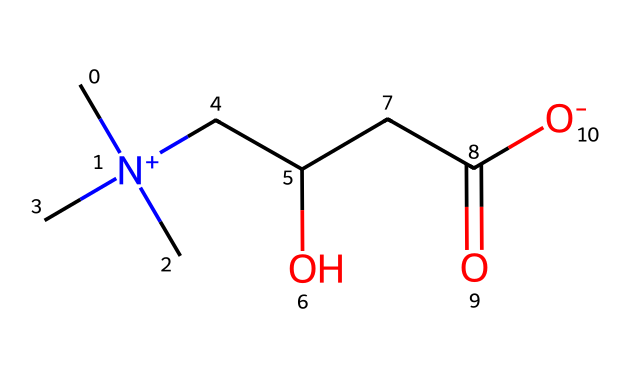What is the full name of this chiral compound? The SMILES representation indicates that the compound contains a positively charged nitrogen atom with three methyl groups attached, a hydroxyl group, and a carboxyl group. Considering these features, the compound is known as L-carnitine.
Answer: L-carnitine How many carbon atoms are in the structure? Upon examining the SMILES notation, we can count a total of seven carbon atoms in the branched structure indicated.
Answer: seven Does this compound have a stereocenter? A stereocenter is present in the structure where the carbon is attached to four different groups: a hydroxyl group, an acyl group, a methyl group, and a longer carbon chain. This confirms it is a chiral compound.
Answer: yes What functional groups are present in L-carnitine? The SMILES representation shows a hydroxyl group (-OH) and a carboxylic acid group (-COOH) along with a quaternary ammonium group. This combination identifies the main functional groups in the structure.
Answer: hydroxyl, carboxylic acid, quaternary ammonium What role does L-carnitine play in the body? L-carnitine is essential for the transport of fatty acids into the mitochondria during metabolism, aiding in energy production, particularly during exercise and recovery.
Answer: fatty acid metabolism 